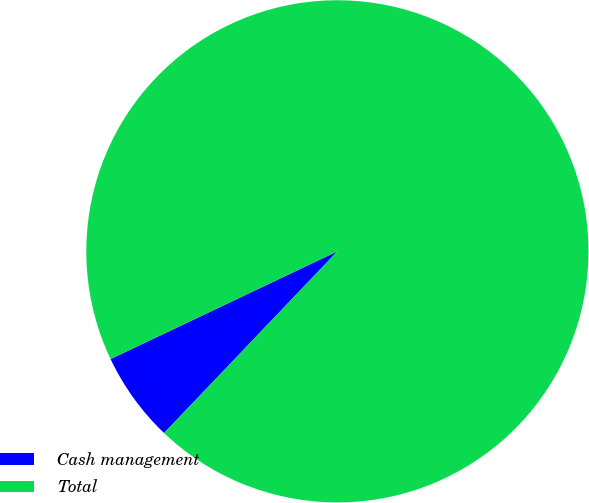Convert chart. <chart><loc_0><loc_0><loc_500><loc_500><pie_chart><fcel>Cash management<fcel>Total<nl><fcel>5.82%<fcel>94.18%<nl></chart> 